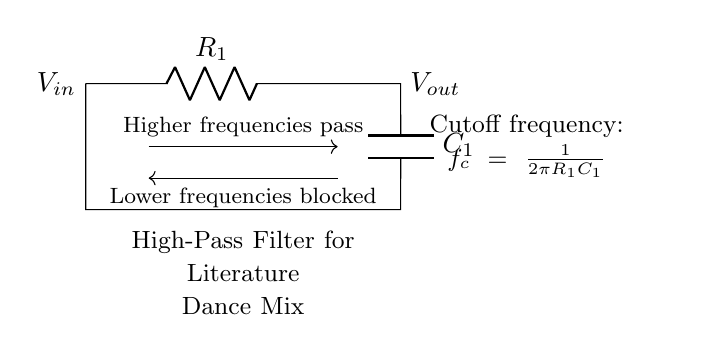What type of filter is depicted in the circuit? The circuit diagram showcases a high-pass filter, which allows higher frequencies to pass through while blocking lower frequencies based on its components' characteristics.
Answer: High-pass filter What are the components used in the circuit? The circuit consists of a resistor (R) and a capacitor (C), specifically labeled as R1 and C1, which are typical components for a high-pass filter to achieve its desired filtering effect.
Answer: Resistor and capacitor What does V_in represent in this circuit? V_in is marked on the left side of the circuit and signifies the input voltage applied to the high-pass filter, which will be processed to allow certain frequencies to pass through.
Answer: Input voltage What is the function of the capacitor in the circuit? The capacitor in the high-pass filter allows only higher frequency signals to pass while blocking lower frequencies by charging and discharging in response to voltage changes, thereby affecting the output accordingly.
Answer: Blocks lower frequencies What is the cutoff frequency formula presented in the diagram? The diagram includes the cutoff frequency formula f_c = 1/(2πR1C1), which mathematically defines the frequency at which the output voltage is reduced to 70.7% of the input voltage, indicating the transition point for the filter.
Answer: f_c = 1/(2πR1C1) What occurs when the frequency of the input signal is below the cutoff frequency? When the frequency of the input signal is below the cutoff frequency, the circuit effectively blocks these lower frequencies, translating to minimal output voltage across V_out due to the nature of high-pass filtering.
Answer: Lower frequencies blocked What does V_out represent in the circuit? V_out is shown on the right side of the circuit and indicates the output voltage that is the result of applying the input voltage through the high-pass filter, reflecting the allowed higher frequencies while attenuating lower ones.
Answer: Output voltage 